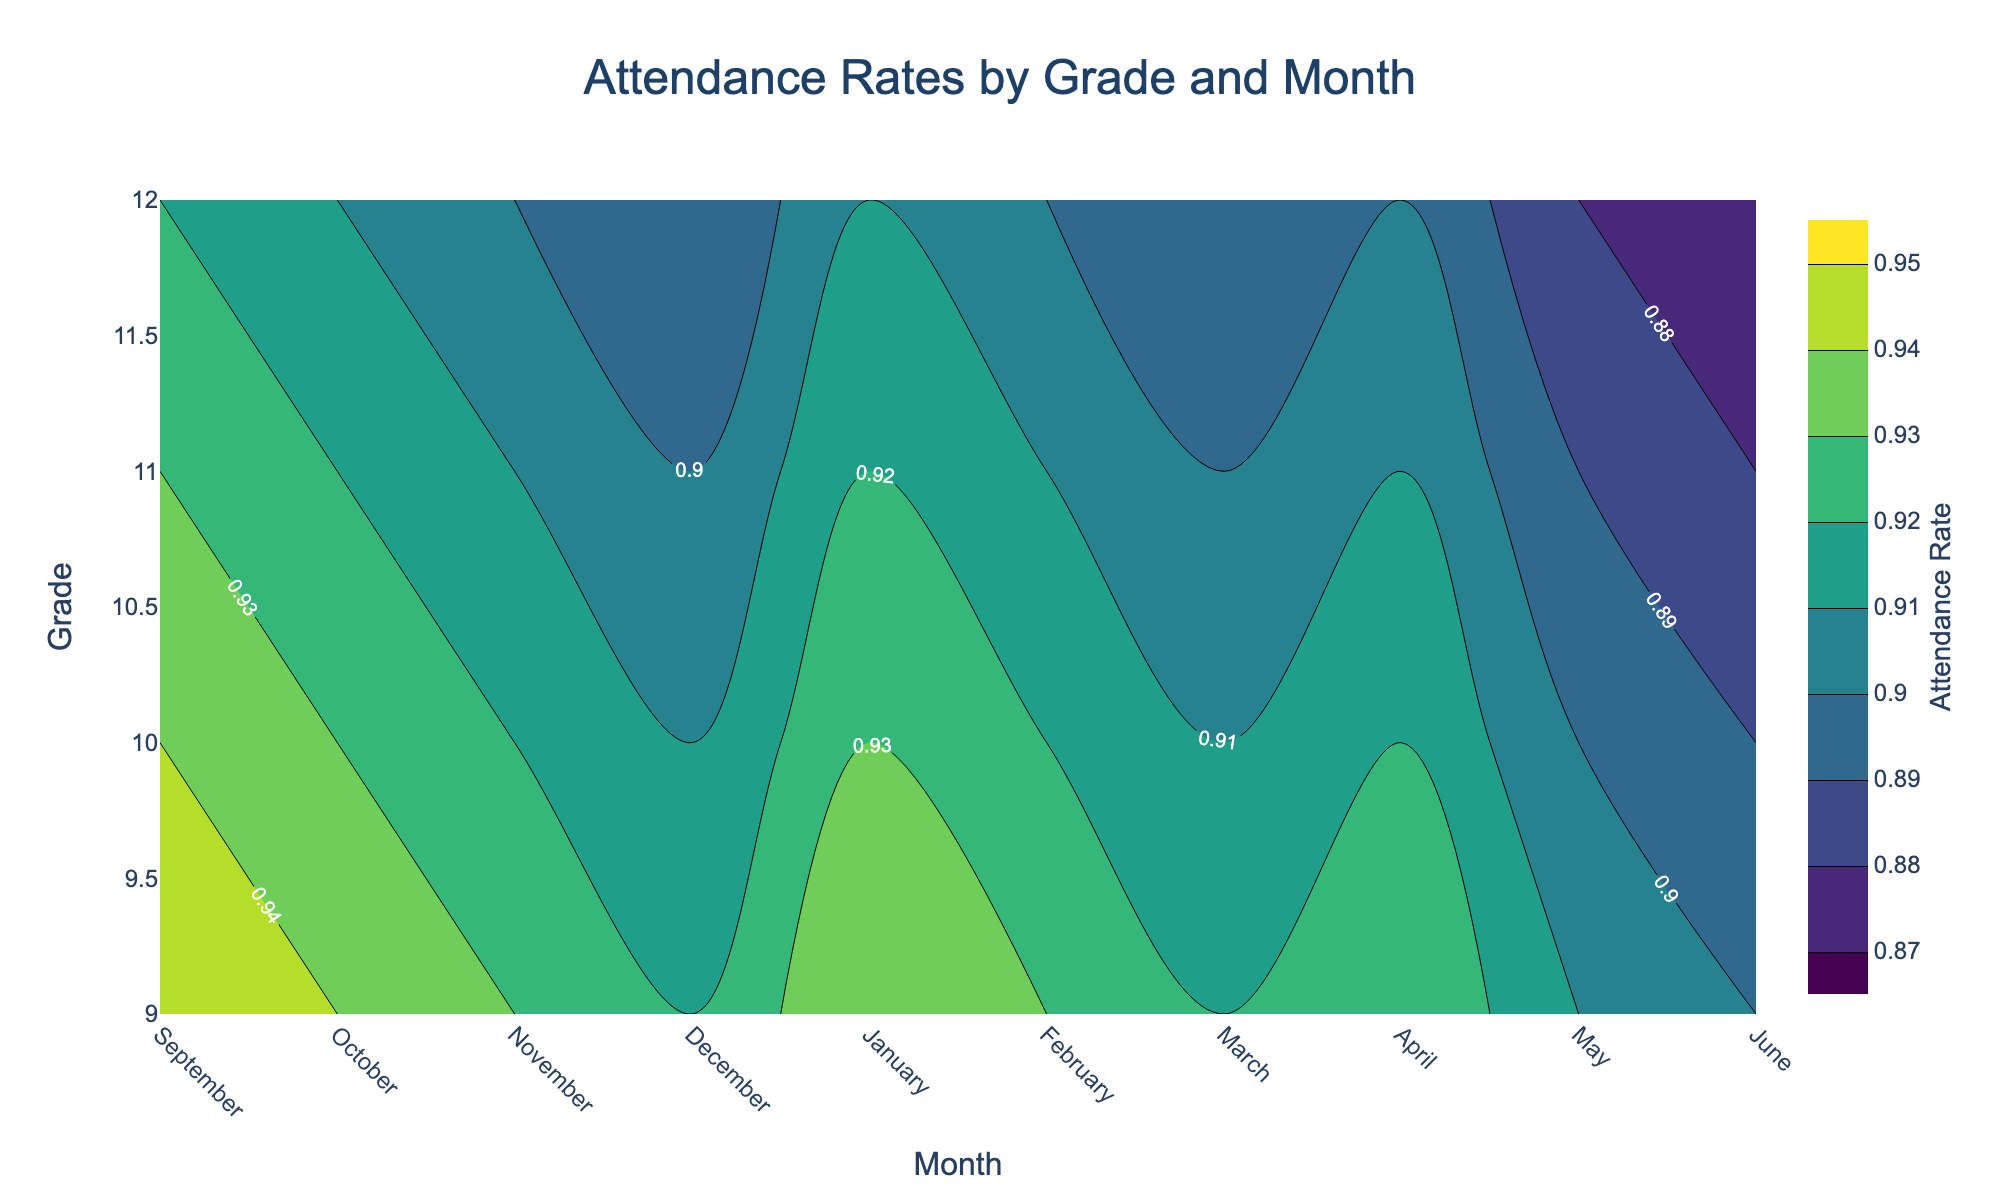What is the title of the contour plot? The title is usually placed at the top of the figure and summarizes what the plot represents. In this case, it is specified within the `update_layout` function.
Answer: Attendance Rates by Grade and Month What is the grade with the highest overall attendance rate in September? To find the grade with the highest attendance rate in September, refer to the values on the y-axis and observe the corresponding z values for September. Grade 9 has the highest value at 0.95.
Answer: Grade 9 Which month showed the lowest attendance rate for 12th-grade students? By examining the contour plot and looking at the y-axis for Grade 12, then tracing horizontally to find the minimum z value, you can see that June shows the lowest attendance rate at 0.87.
Answer: June Is there a noticeable trend in attendance rates from September to June across all grades? To identify trends, observe the color gradient from left (September) to right (June) across the grades. The colors show a general decrease in attendance rates from September to June for all grades.
Answer: Decrease What is the difference in the attendance rate for 10th-grade students between January and May? Locate January and May on the x-axis, then find the corresponding attendance rates for Grade 10. The rate in January is 0.93, and in May, it's 0.90. Subtract the May rate from the January rate: 0.93 - 0.90 = 0.03.
Answer: 0.03 Which grade has the smallest range of attendance rates over the year? To determine the smallest range, compare the minimum and maximum attendance rates for each grade. Grade 9 ranges from 0.90 to 0.95, Grade 10 from 0.89 to 0.94, Grade 11 from 0.88 to 0.93, and Grade 12 from 0.87 to 0.92. Grade 9 has the smallest range of 0.05.
Answer: Grade 9 In which month is the attendance rate for Grade 11 closest to the overall average for Grade 11? Calculate the average attendance rate for Grade 11, which is (0.93 + 0.92 + 0.91 + 0.90 + 0.92 + 0.91 + 0.90 + 0.91 + 0.89 + 0.88) / 10 = 0.907. Then find the month where the rate is closest to this value. In March, the attendance rate is 0.90, which is closest to 0.907.
Answer: March How is the contour pattern different for Grade 11 compared to Grade 9? To compare patterns, observe the color gradients for both grades. Grade 9 shows higher overall values with less variation through the months, while Grade 11 shows a more pronounced decline and wider range, indicating a steeper drop-off in attendance over the school year.
Answer: Steeper decline in Grade 11 What is the average attendance rate for all grades in December? To find the average for December, sum the attendance rates for all grades in December and divide by the number of grades: (0.92 + 0.91 + 0.90 + 0.89) / 4 = 0.905.
Answer: 0.905 